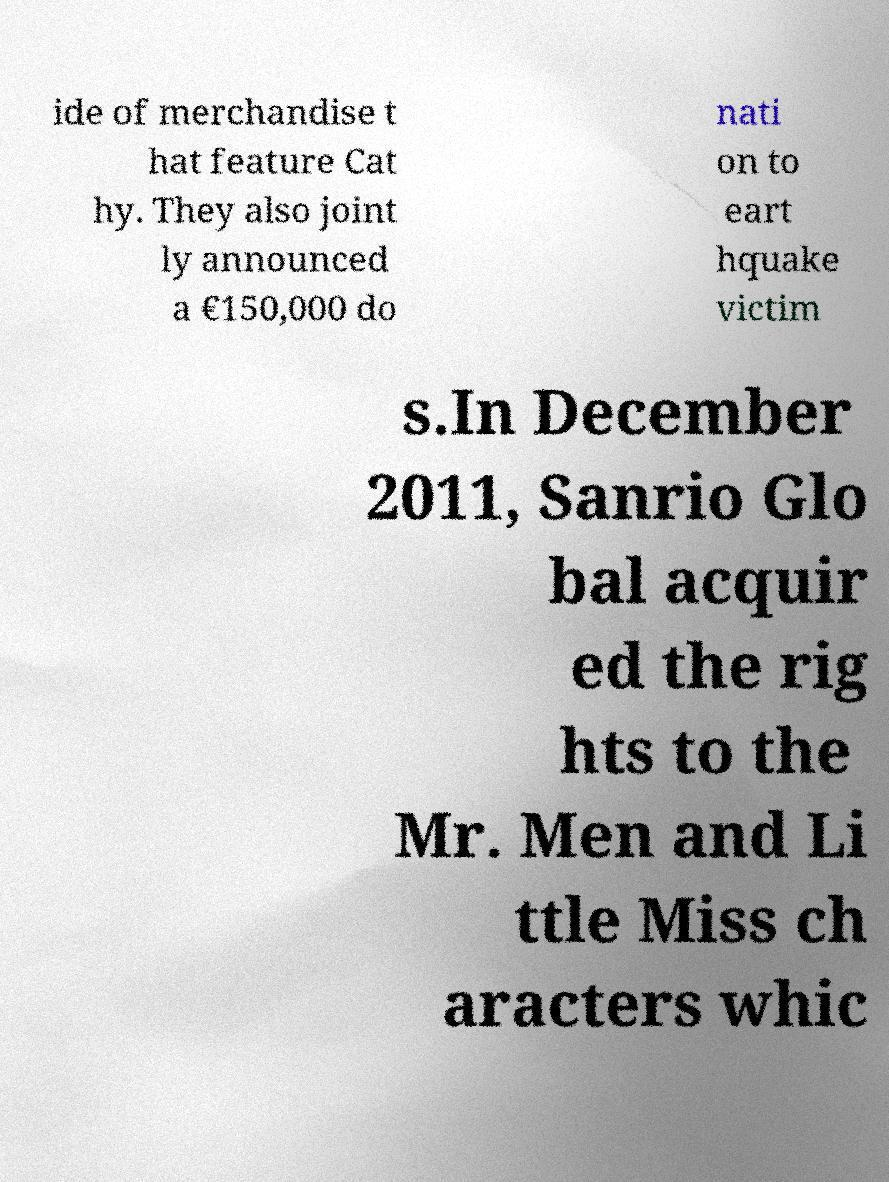Please read and relay the text visible in this image. What does it say? ide of merchandise t hat feature Cat hy. They also joint ly announced a €150,000 do nati on to eart hquake victim s.In December 2011, Sanrio Glo bal acquir ed the rig hts to the Mr. Men and Li ttle Miss ch aracters whic 